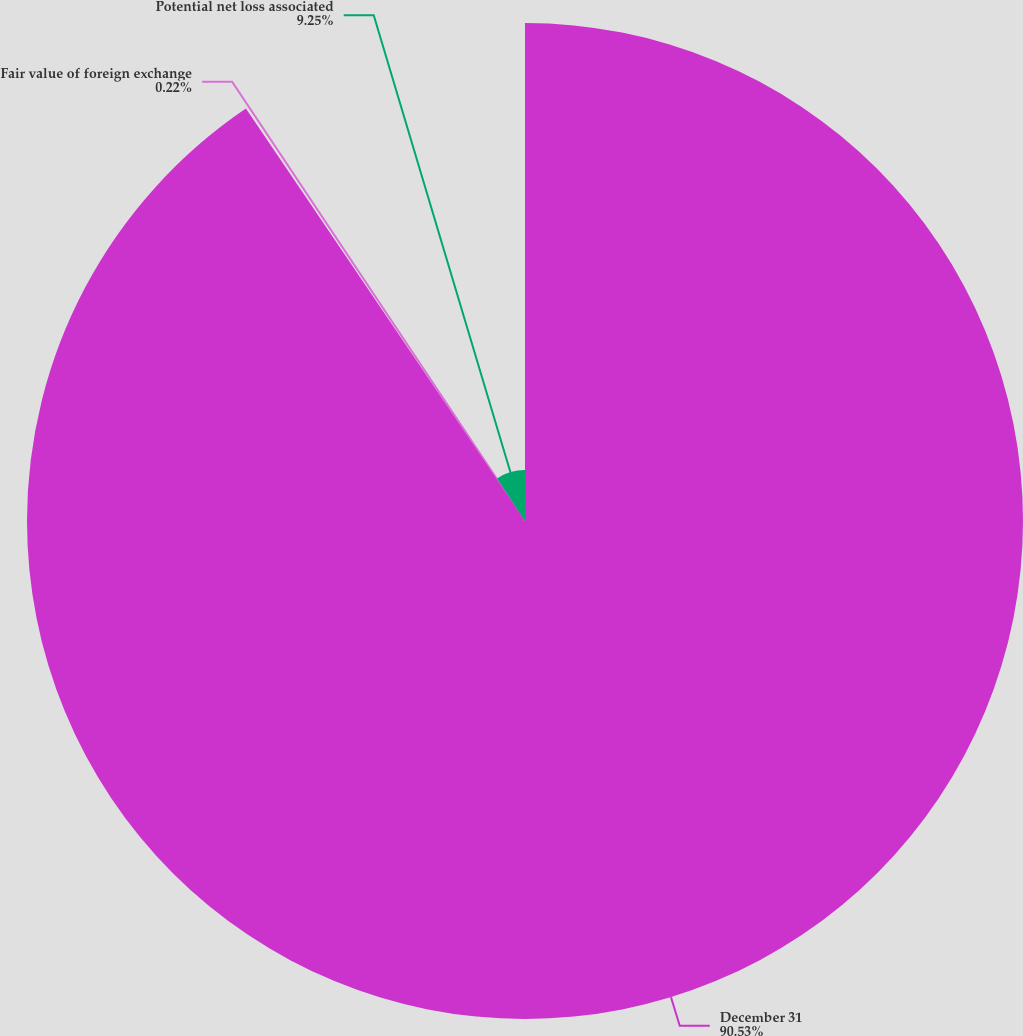<chart> <loc_0><loc_0><loc_500><loc_500><pie_chart><fcel>December 31<fcel>Fair value of foreign exchange<fcel>Potential net loss associated<nl><fcel>90.54%<fcel>0.22%<fcel>9.25%<nl></chart> 